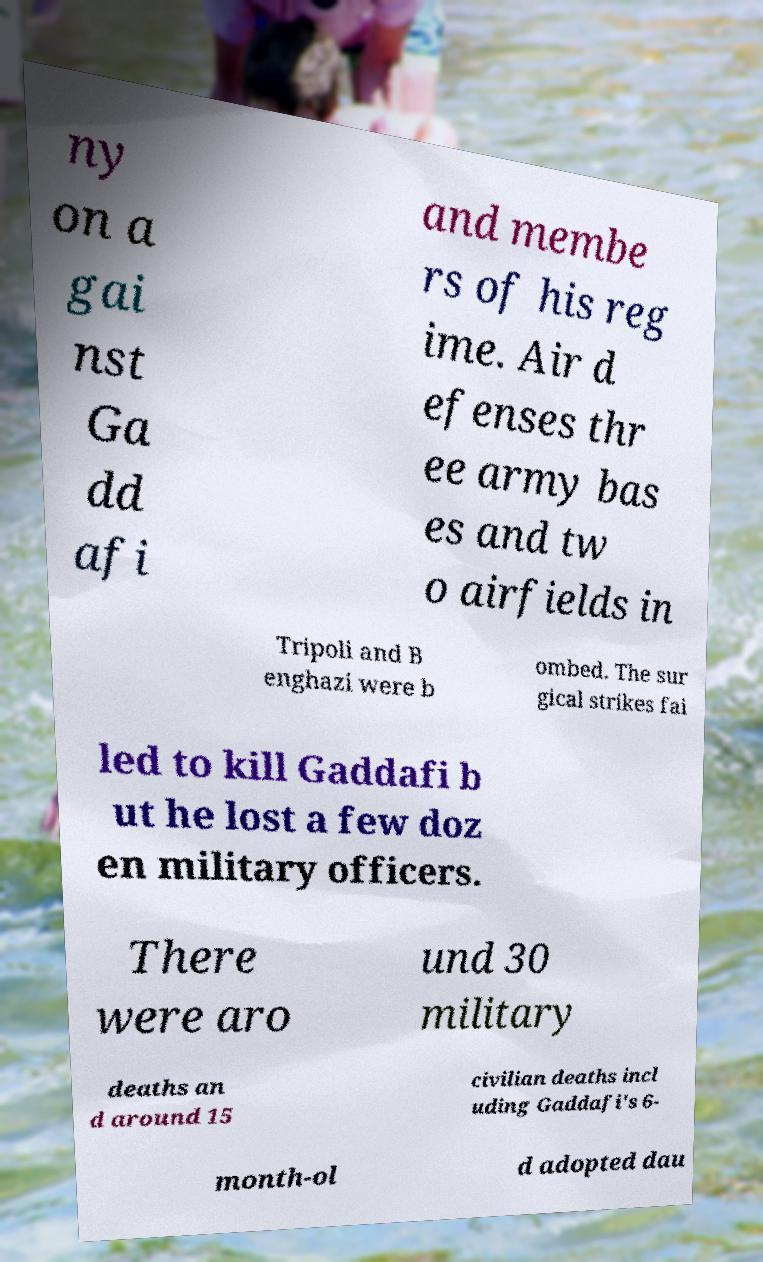I need the written content from this picture converted into text. Can you do that? ny on a gai nst Ga dd afi and membe rs of his reg ime. Air d efenses thr ee army bas es and tw o airfields in Tripoli and B enghazi were b ombed. The sur gical strikes fai led to kill Gaddafi b ut he lost a few doz en military officers. There were aro und 30 military deaths an d around 15 civilian deaths incl uding Gaddafi's 6- month-ol d adopted dau 